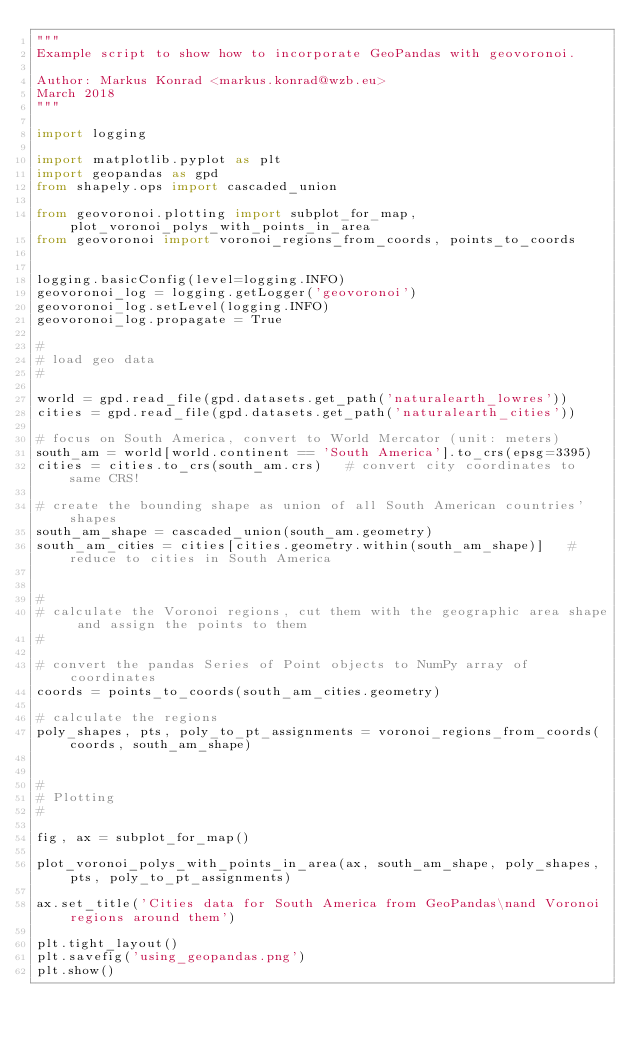Convert code to text. <code><loc_0><loc_0><loc_500><loc_500><_Python_>"""
Example script to show how to incorporate GeoPandas with geovoronoi.

Author: Markus Konrad <markus.konrad@wzb.eu>
March 2018
"""

import logging

import matplotlib.pyplot as plt
import geopandas as gpd
from shapely.ops import cascaded_union

from geovoronoi.plotting import subplot_for_map, plot_voronoi_polys_with_points_in_area
from geovoronoi import voronoi_regions_from_coords, points_to_coords


logging.basicConfig(level=logging.INFO)
geovoronoi_log = logging.getLogger('geovoronoi')
geovoronoi_log.setLevel(logging.INFO)
geovoronoi_log.propagate = True

#
# load geo data
#

world = gpd.read_file(gpd.datasets.get_path('naturalearth_lowres'))
cities = gpd.read_file(gpd.datasets.get_path('naturalearth_cities'))

# focus on South America, convert to World Mercator (unit: meters)
south_am = world[world.continent == 'South America'].to_crs(epsg=3395)
cities = cities.to_crs(south_am.crs)   # convert city coordinates to same CRS!

# create the bounding shape as union of all South American countries' shapes
south_am_shape = cascaded_union(south_am.geometry)
south_am_cities = cities[cities.geometry.within(south_am_shape)]   # reduce to cities in South America


#
# calculate the Voronoi regions, cut them with the geographic area shape and assign the points to them
#

# convert the pandas Series of Point objects to NumPy array of coordinates
coords = points_to_coords(south_am_cities.geometry)

# calculate the regions
poly_shapes, pts, poly_to_pt_assignments = voronoi_regions_from_coords(coords, south_am_shape)


#
# Plotting
#

fig, ax = subplot_for_map()

plot_voronoi_polys_with_points_in_area(ax, south_am_shape, poly_shapes, pts, poly_to_pt_assignments)

ax.set_title('Cities data for South America from GeoPandas\nand Voronoi regions around them')

plt.tight_layout()
plt.savefig('using_geopandas.png')
plt.show()


</code> 